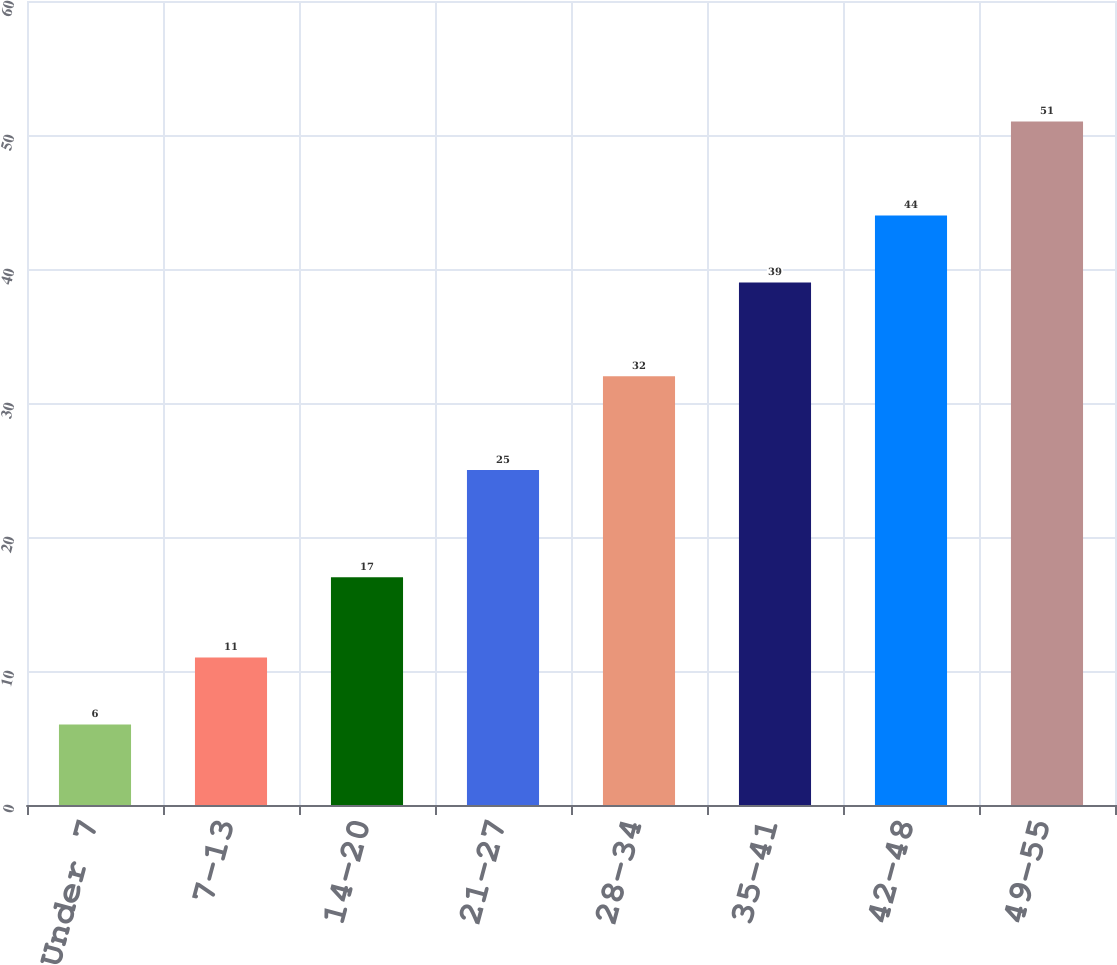<chart> <loc_0><loc_0><loc_500><loc_500><bar_chart><fcel>Under 7<fcel>7-13<fcel>14-20<fcel>21-27<fcel>28-34<fcel>35-41<fcel>42-48<fcel>49-55<nl><fcel>6<fcel>11<fcel>17<fcel>25<fcel>32<fcel>39<fcel>44<fcel>51<nl></chart> 